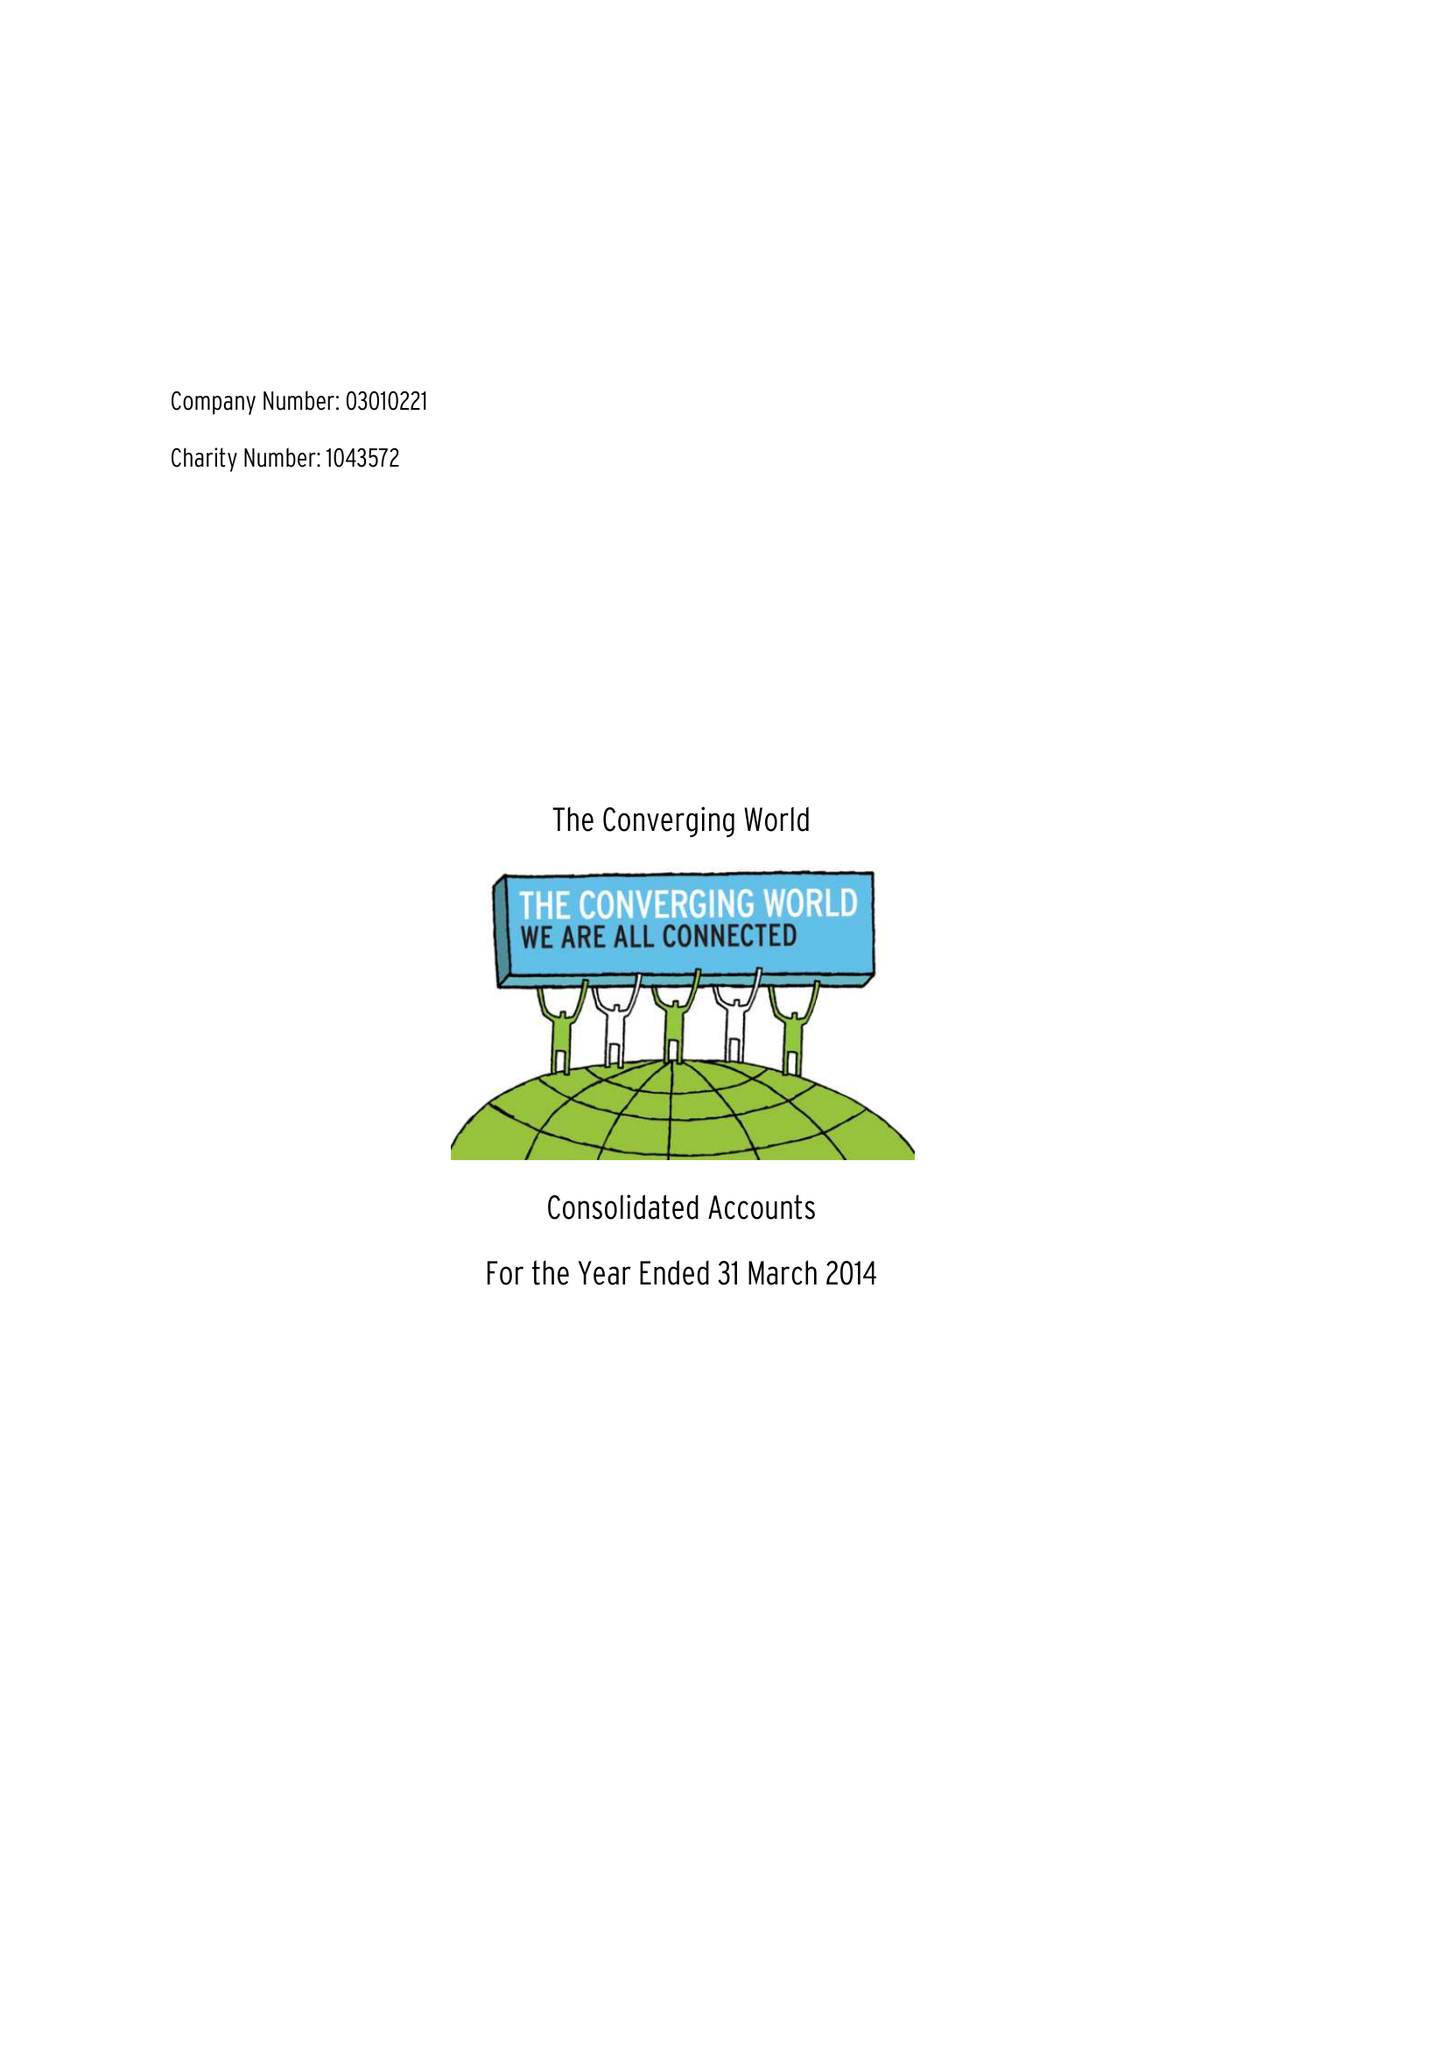What is the value for the charity_name?
Answer the question using a single word or phrase. The Converging World 